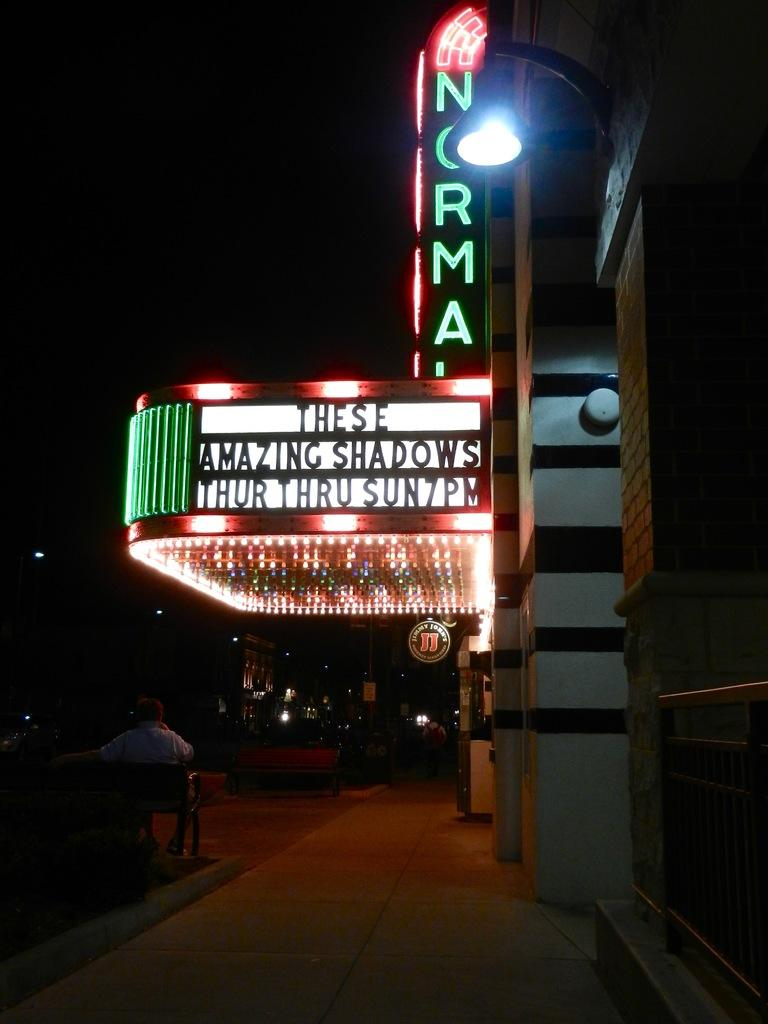What is located in the foreground of the picture? In the foreground of the picture, there is a board, a light, text, a person, a chair, a building, and a footpath. Can you describe the person in the foreground of the picture? There is a person in the foreground of the picture, but their appearance or clothing is not mentioned in the facts. What can be seen in the background of the picture? In the background of the picture, there are buildings, roads, a light, and sky visible. What type of surface is the person standing on in the foreground of the picture? The person is standing on a footpath in the foreground of the picture. What type of butter is being used to write the text on the board in the image? There is no mention of butter in the image or the provided facts. 